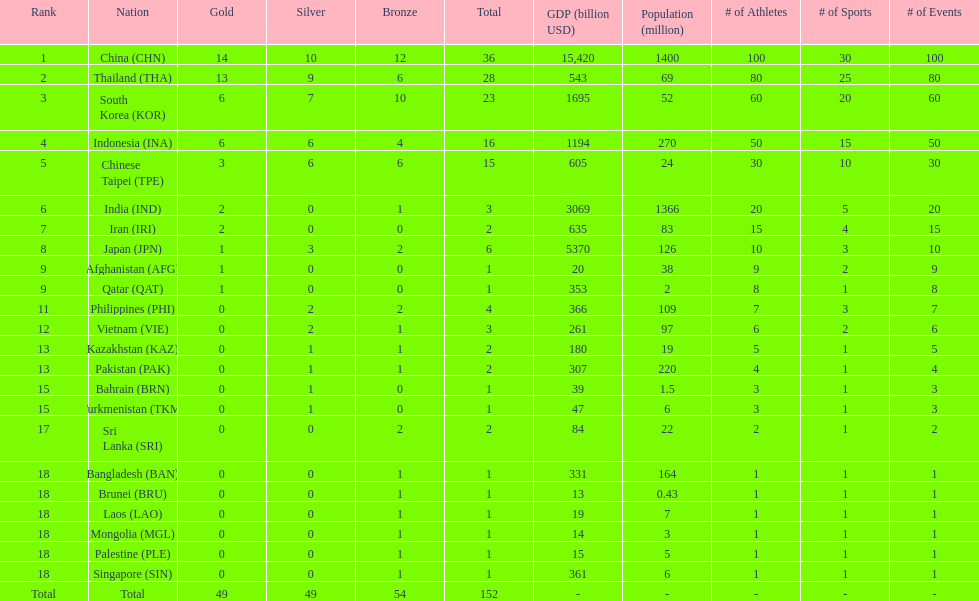What is the total number of nations that participated in the beach games of 2012? 23. 